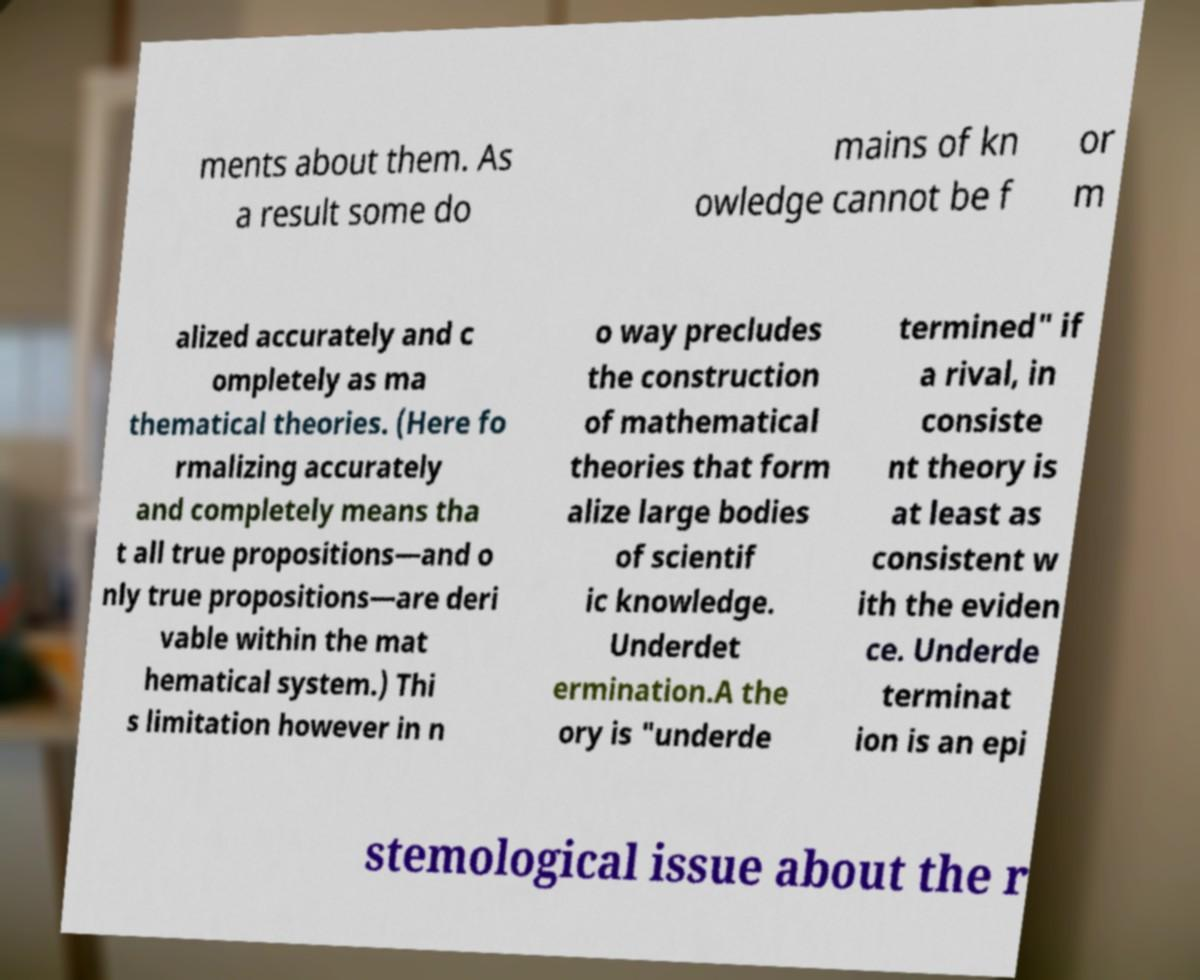Could you assist in decoding the text presented in this image and type it out clearly? ments about them. As a result some do mains of kn owledge cannot be f or m alized accurately and c ompletely as ma thematical theories. (Here fo rmalizing accurately and completely means tha t all true propositions—and o nly true propositions—are deri vable within the mat hematical system.) Thi s limitation however in n o way precludes the construction of mathematical theories that form alize large bodies of scientif ic knowledge. Underdet ermination.A the ory is "underde termined" if a rival, in consiste nt theory is at least as consistent w ith the eviden ce. Underde terminat ion is an epi stemological issue about the r 